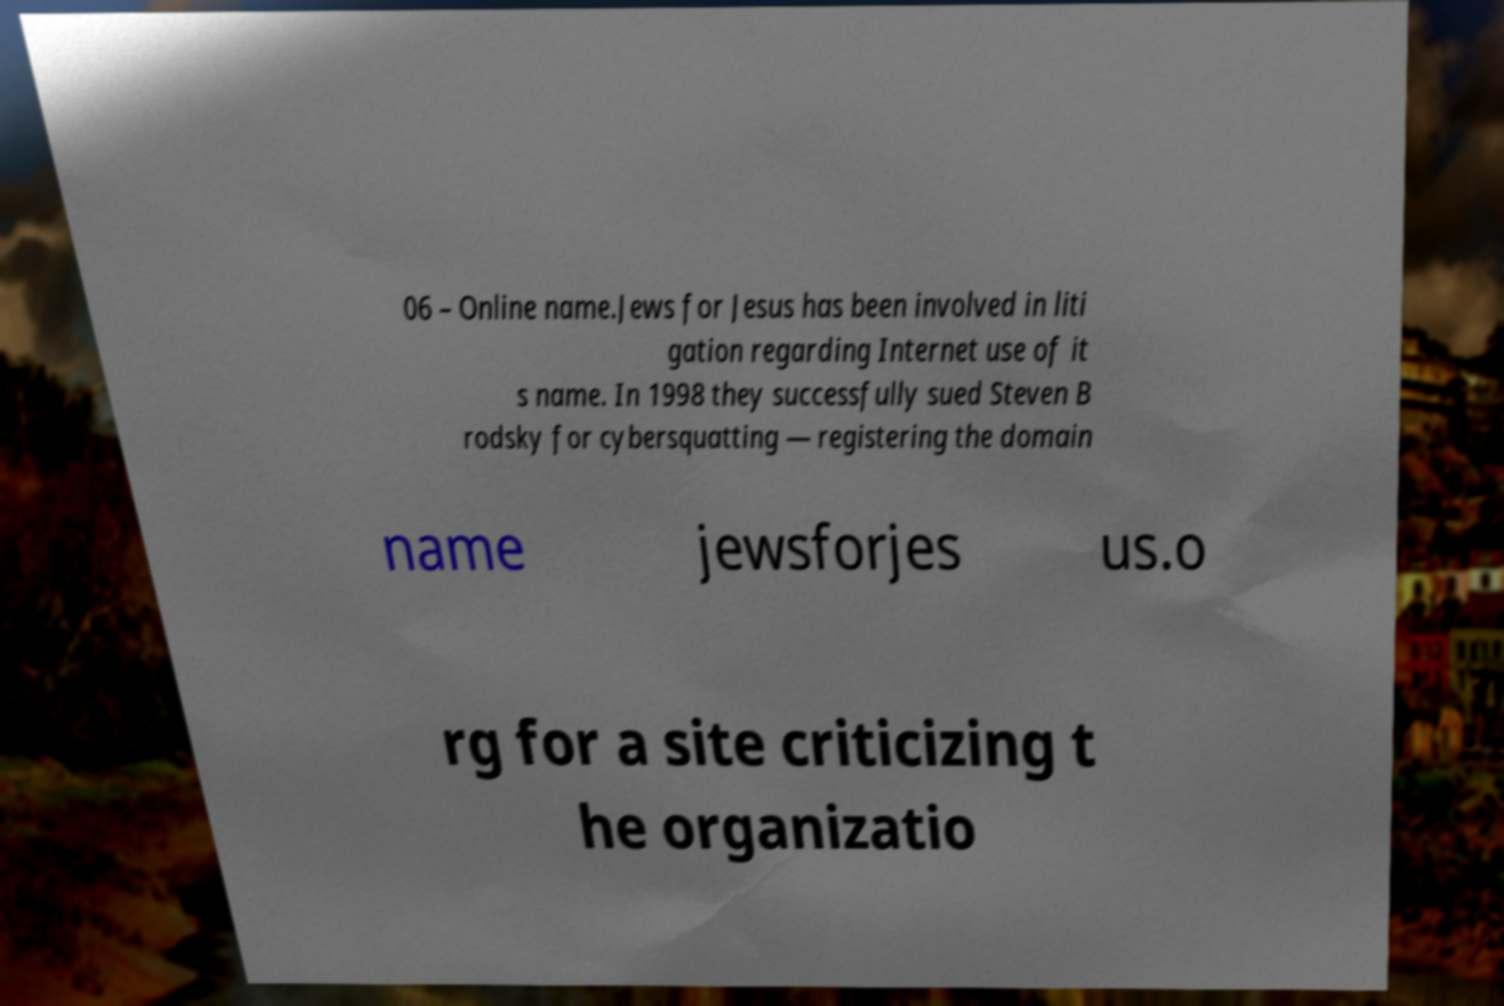Can you read and provide the text displayed in the image?This photo seems to have some interesting text. Can you extract and type it out for me? 06 – Online name.Jews for Jesus has been involved in liti gation regarding Internet use of it s name. In 1998 they successfully sued Steven B rodsky for cybersquatting — registering the domain name jewsforjes us.o rg for a site criticizing t he organizatio 